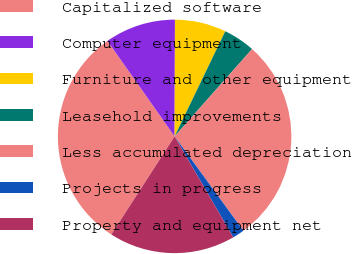<chart> <loc_0><loc_0><loc_500><loc_500><pie_chart><fcel>Capitalized software<fcel>Computer equipment<fcel>Furniture and other equipment<fcel>Leasehold improvements<fcel>Less accumulated depreciation<fcel>Projects in progress<fcel>Property and equipment net<nl><fcel>31.13%<fcel>9.8%<fcel>7.1%<fcel>4.4%<fcel>28.43%<fcel>1.65%<fcel>17.49%<nl></chart> 